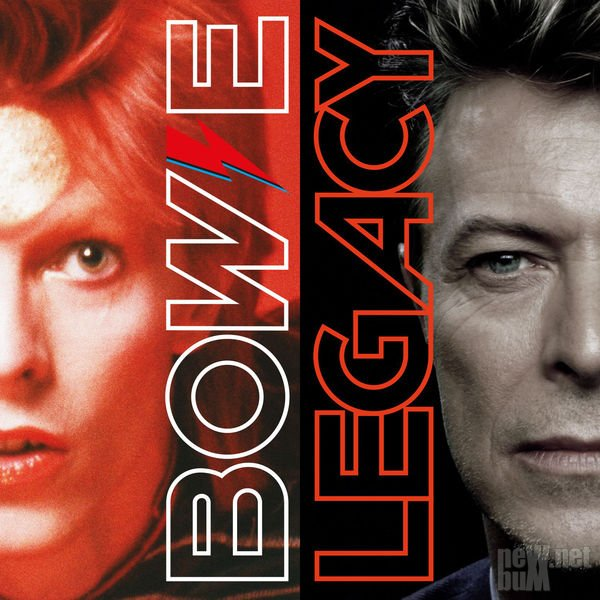Discuss the legacy left by the individual represented in the right portrait. The individual represented in the right portrait leaves a profound legacy characterized by innovation, versatility, and influence. Their career is marked by continual reinvention, pushing the boundaries of music, art, and performance. Through a diverse array of personas and creative expressions, they have left an indelible mark on pop culture, inspiring generations of artists and fans. Their work spans several decades, reflecting a deep connection with societal changes and artistic evolution. This legacy is celebrated not only for its artistic achievements but also for its impact on shaping modern cultural and aesthetic sensibilities. How might fans honor the legacy of this individual? Fans might honor the legacy of this individual by celebrating their artistic contributions through tribute concerts, exhibitions, and festivals. Creating spaces for fans to share their personal stories and experiences related to the individual's work can also be a heartfelt homage. Engaging with the artist's material—listening to their music, watching performances, and exploring their visual art—ensures that their creative spirit remains alive. Fans could also participate in or support initiatives that reflect the values and innovation championed by the individual, thereby continuing the legacy of creativity and cultural impact. 